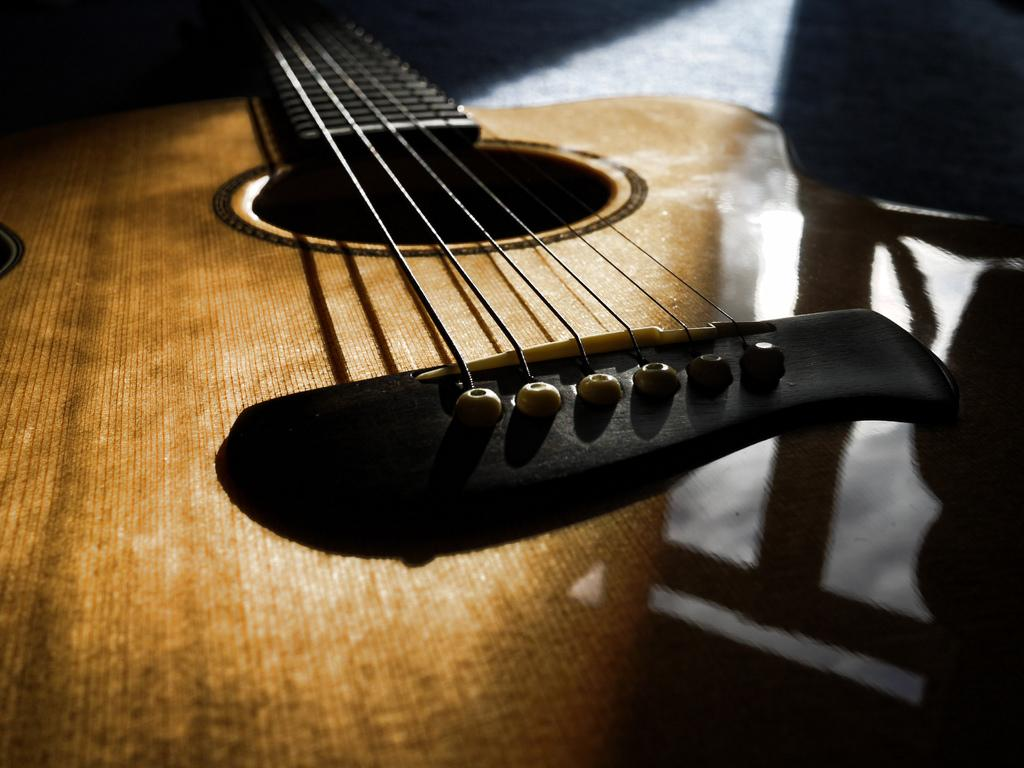What musical instrument is present in the image? There is a guitar in the image. What is the color of the guitar? The guitar is brown in color. What feature of the guitar allows it to produce sound? The guitar has strings. What type of muscle can be seen flexing on the guitar in the image? There is no muscle visible on the guitar in the image, as it is an inanimate object. 